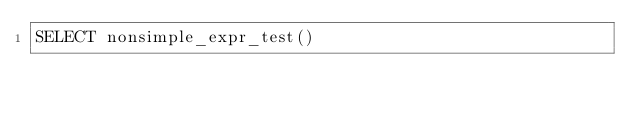Convert code to text. <code><loc_0><loc_0><loc_500><loc_500><_SQL_>SELECT nonsimple_expr_test()
</code> 